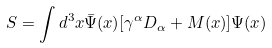Convert formula to latex. <formula><loc_0><loc_0><loc_500><loc_500>S = \int d ^ { 3 } x \bar { \Psi } ( x ) [ \gamma ^ { \alpha } D _ { \alpha } + M ( x ) ] \Psi ( x )</formula> 